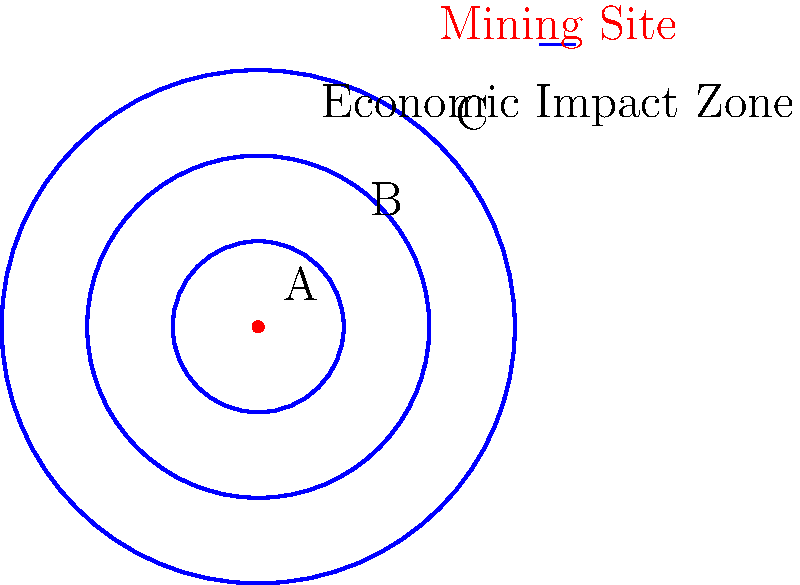In the diagram, a mining site is represented at the center, with concentric circles indicating zones of economic impact. If the economic impact diminishes by 40% for each successive zone moving outward, and Zone A has an economic impact of $100 million, what is the approximate economic impact in Zone C? To solve this problem, we need to follow these steps:

1. Identify the starting economic impact in Zone A: $100 million

2. Calculate the impact reduction for each zone:
   - Reduction rate = 40% = 0.4
   - Remaining impact = 1 - 0.4 = 0.6 or 60%

3. Calculate the impact in Zone B:
   - Zone B impact = Zone A impact × Remaining impact
   - Zone B impact = $100 million × 0.6 = $60 million

4. Calculate the impact in Zone C:
   - Zone C impact = Zone B impact × Remaining impact
   - Zone C impact = $60 million × 0.6 = $36 million

Therefore, the economic impact in Zone C is approximately $36 million.
Answer: $36 million 